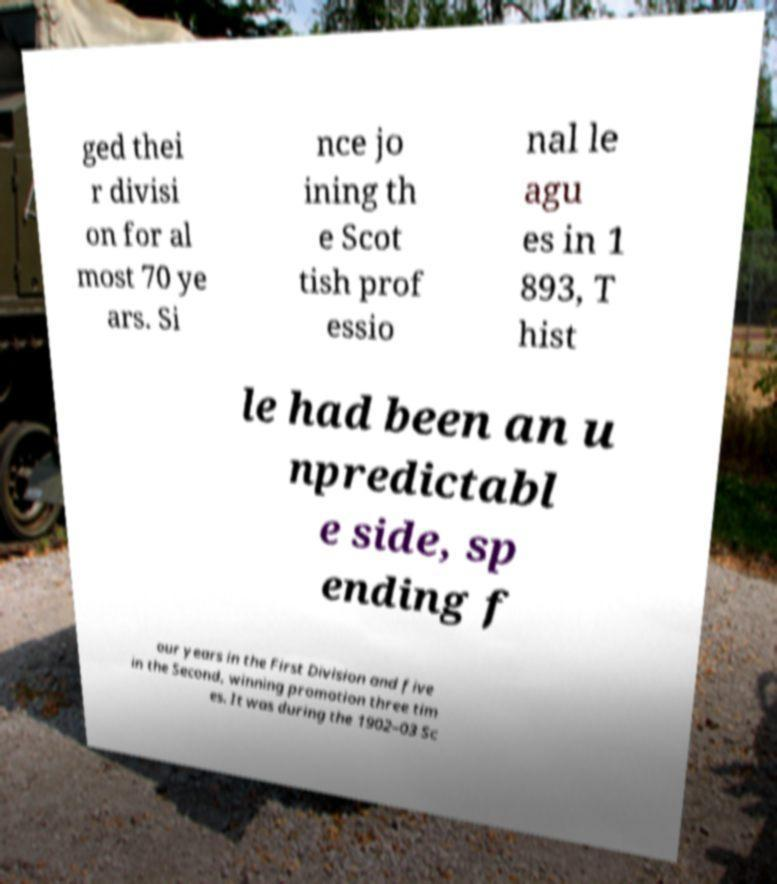I need the written content from this picture converted into text. Can you do that? ged thei r divisi on for al most 70 ye ars. Si nce jo ining th e Scot tish prof essio nal le agu es in 1 893, T hist le had been an u npredictabl e side, sp ending f our years in the First Division and five in the Second, winning promotion three tim es. It was during the 1902–03 Sc 